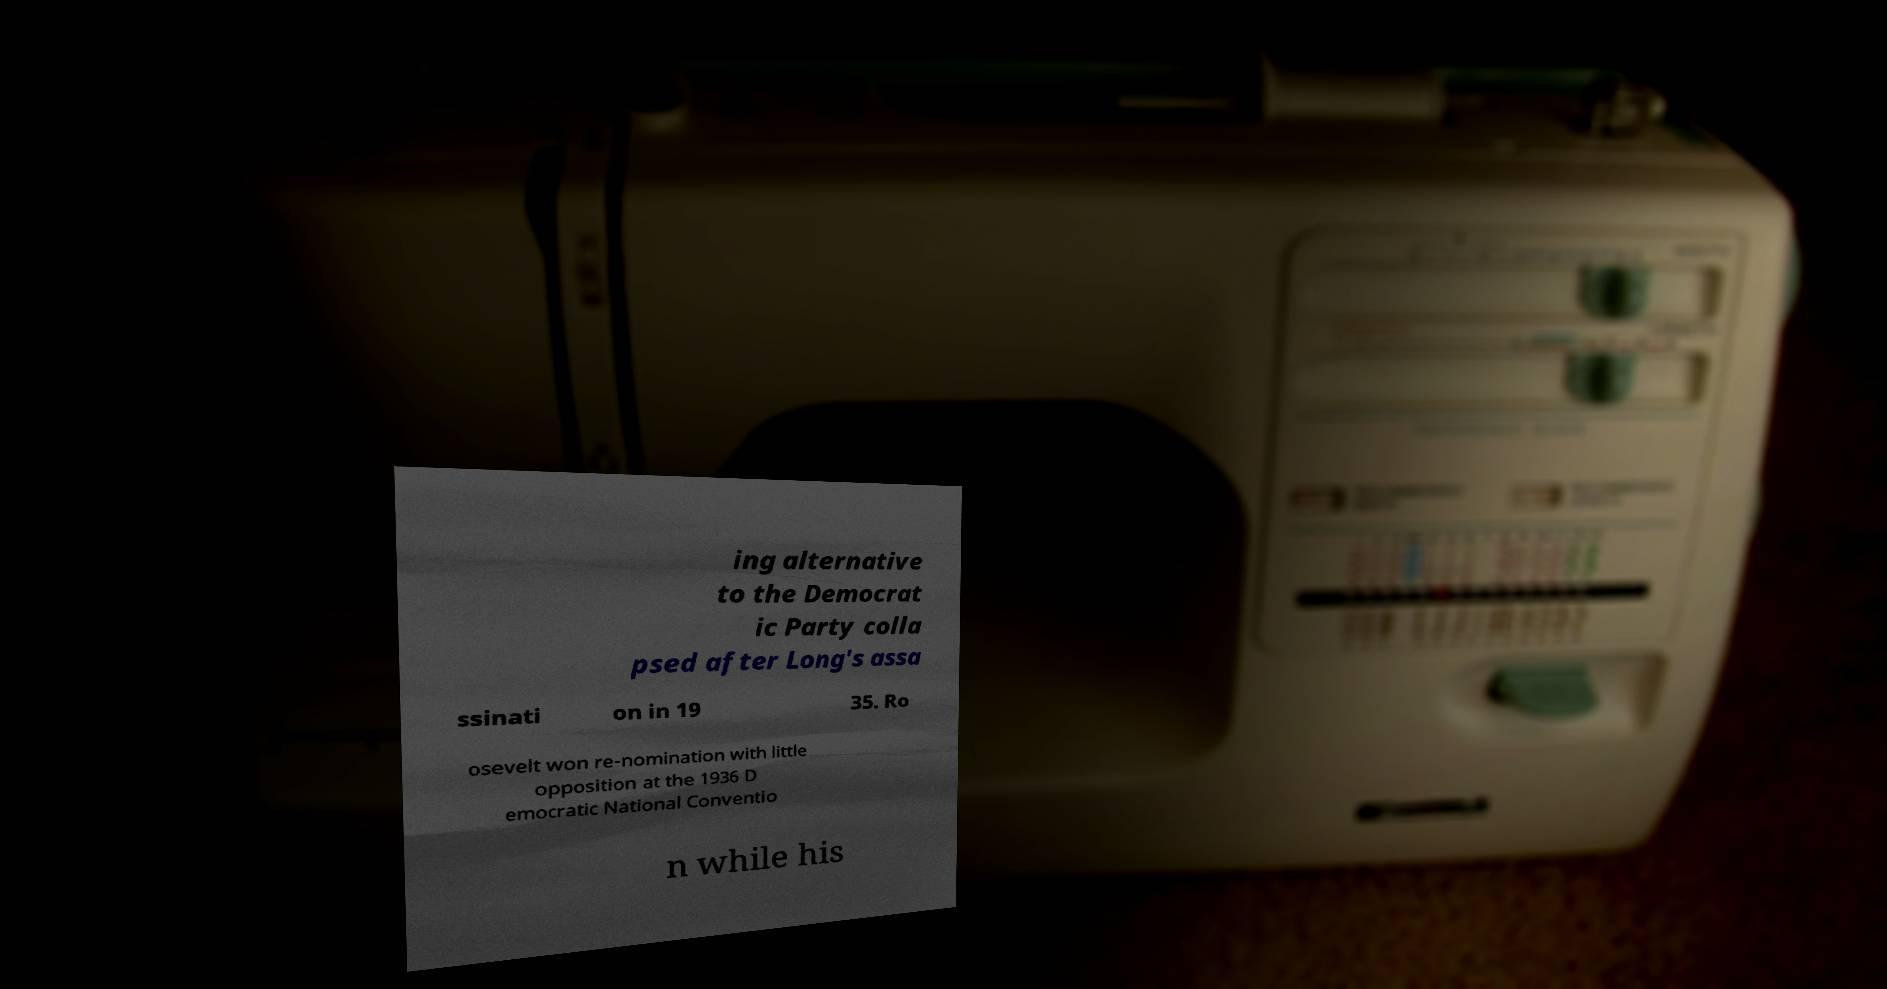I need the written content from this picture converted into text. Can you do that? ing alternative to the Democrat ic Party colla psed after Long's assa ssinati on in 19 35. Ro osevelt won re-nomination with little opposition at the 1936 D emocratic National Conventio n while his 